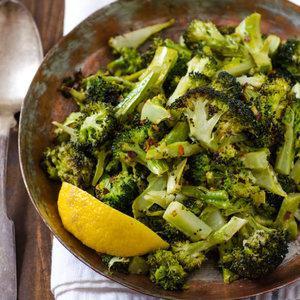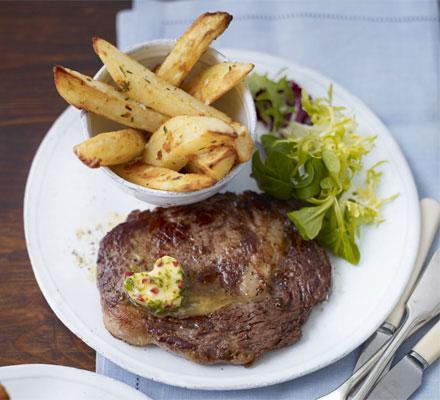The first image is the image on the left, the second image is the image on the right. For the images displayed, is the sentence "There are carrots on the plate in the image on the left." factually correct? Answer yes or no. No. 